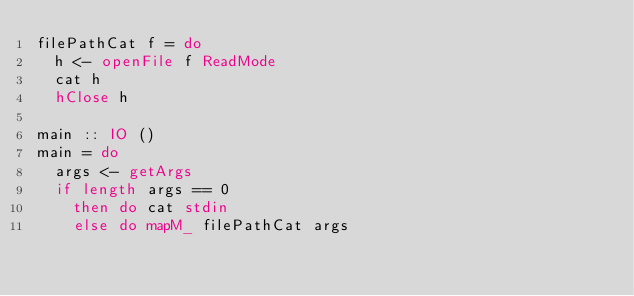Convert code to text. <code><loc_0><loc_0><loc_500><loc_500><_Haskell_>filePathCat f = do
  h <- openFile f ReadMode
  cat h
  hClose h

main :: IO ()
main = do
  args <- getArgs
  if length args == 0
    then do cat stdin
    else do mapM_ filePathCat args
</code> 